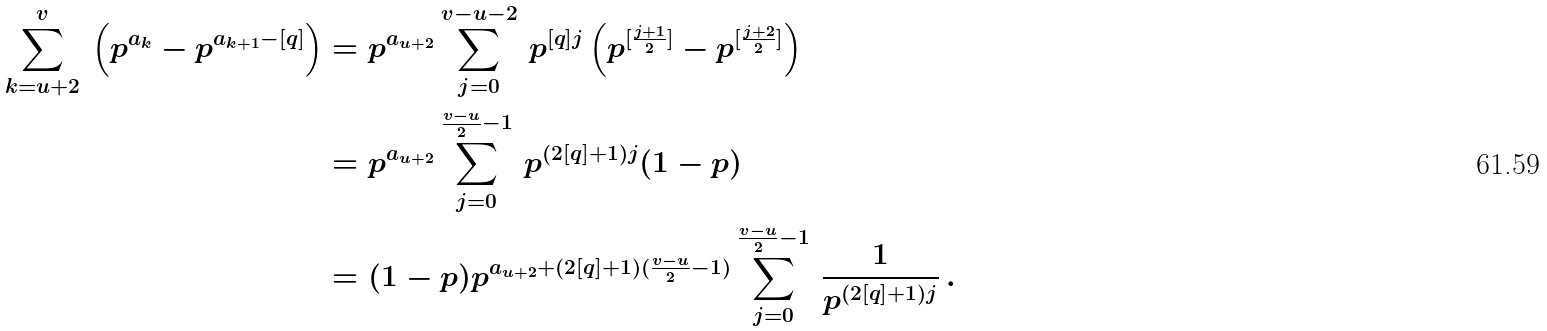Convert formula to latex. <formula><loc_0><loc_0><loc_500><loc_500>\sum _ { k = u + 2 } ^ { v } \, \left ( p ^ { a _ { k } } - p ^ { a _ { k + 1 } - [ q ] } \right ) & = p ^ { a _ { u + 2 } } \sum _ { j = 0 } ^ { v - u - 2 } \, p ^ { [ q ] j } \left ( p ^ { [ \frac { j + 1 } { 2 } ] } - p ^ { [ \frac { j + 2 } { 2 } ] } \right ) \\ & = p ^ { a _ { u + 2 } } \sum _ { j = 0 } ^ { \frac { v - u } { 2 } - 1 } \, p ^ { ( 2 [ q ] + 1 ) j } ( 1 - p ) \\ & = ( 1 - p ) p ^ { a _ { u + 2 } + ( 2 [ q ] + 1 ) ( \frac { v - u } { 2 } - 1 ) } \sum _ { j = 0 } ^ { \frac { v - u } { 2 } - 1 } \, \frac { 1 } { p ^ { ( 2 [ q ] + 1 ) j } } \, .</formula> 